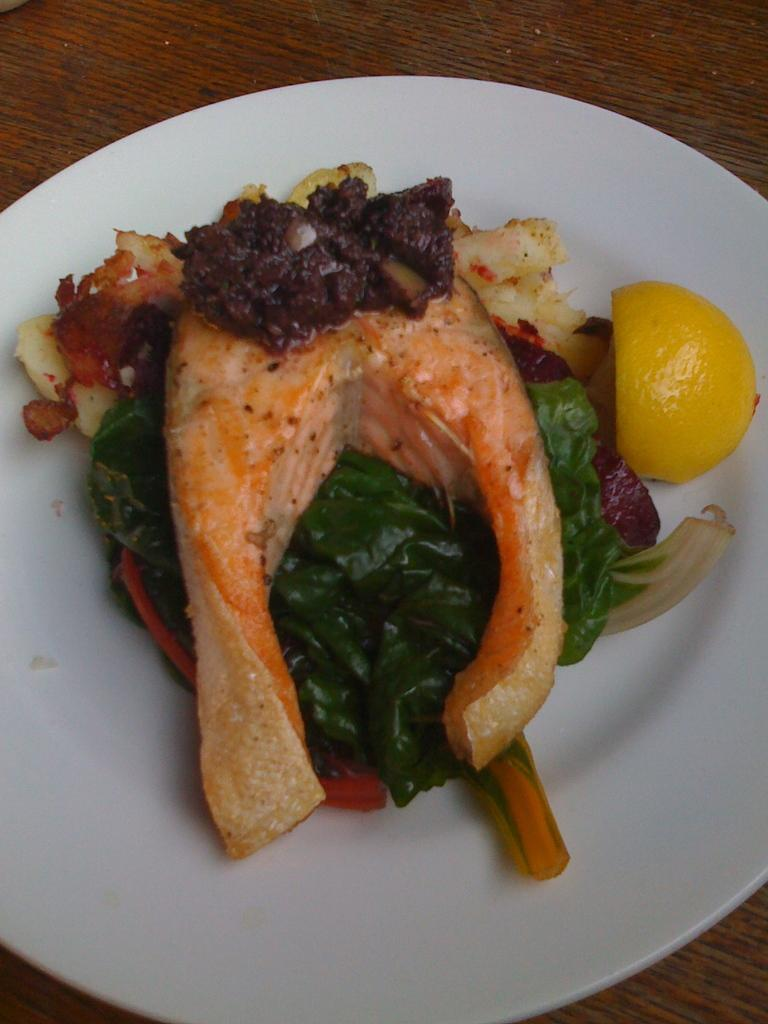What type of food can be seen in the foreground of the image? There is meat and leafy vegetables in the foreground of the image. What other item is present on the platter with the meat and vegetables? There is a piece of lemon in the foreground of the image. How are the food items arranged in the image? The items are on a platter. What is the platter placed on in the image? The platter is on a wooden surface. How many beds are visible in the image? There are no beds present in the image; it features food items on a platter. What type of shock can be seen affecting the vegetables in the image? There is no shock present in the image; the vegetables are simply arranged on a platter. 